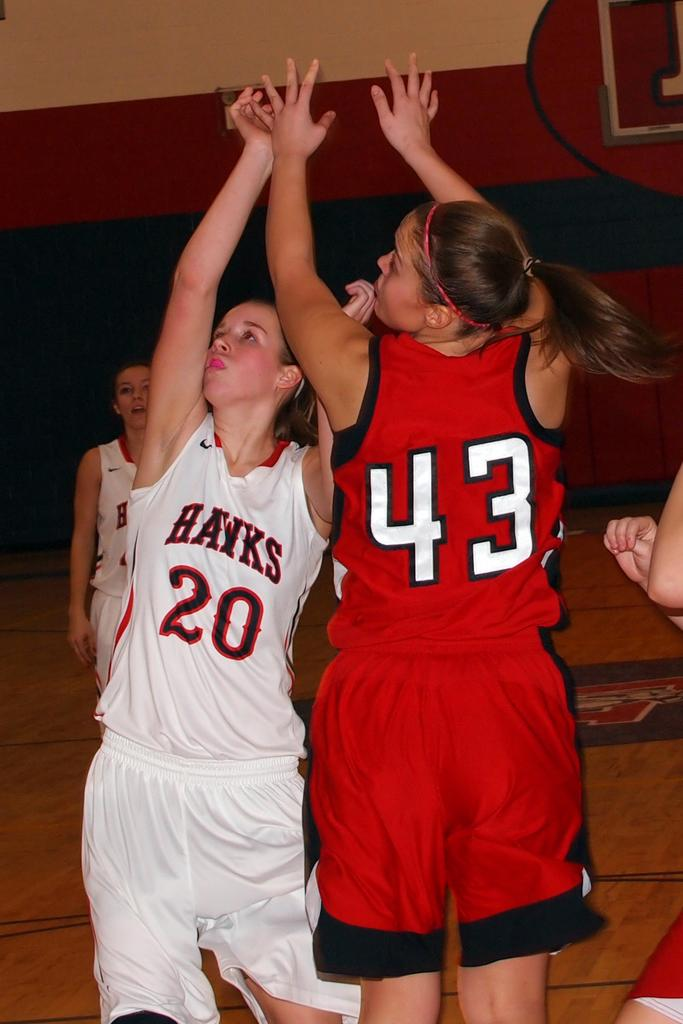<image>
Create a compact narrative representing the image presented. Two basketball players, one wearing white and the number 20 and with the word Hawks on her top jumps alongside another wearing red with the number 43 on her back. 